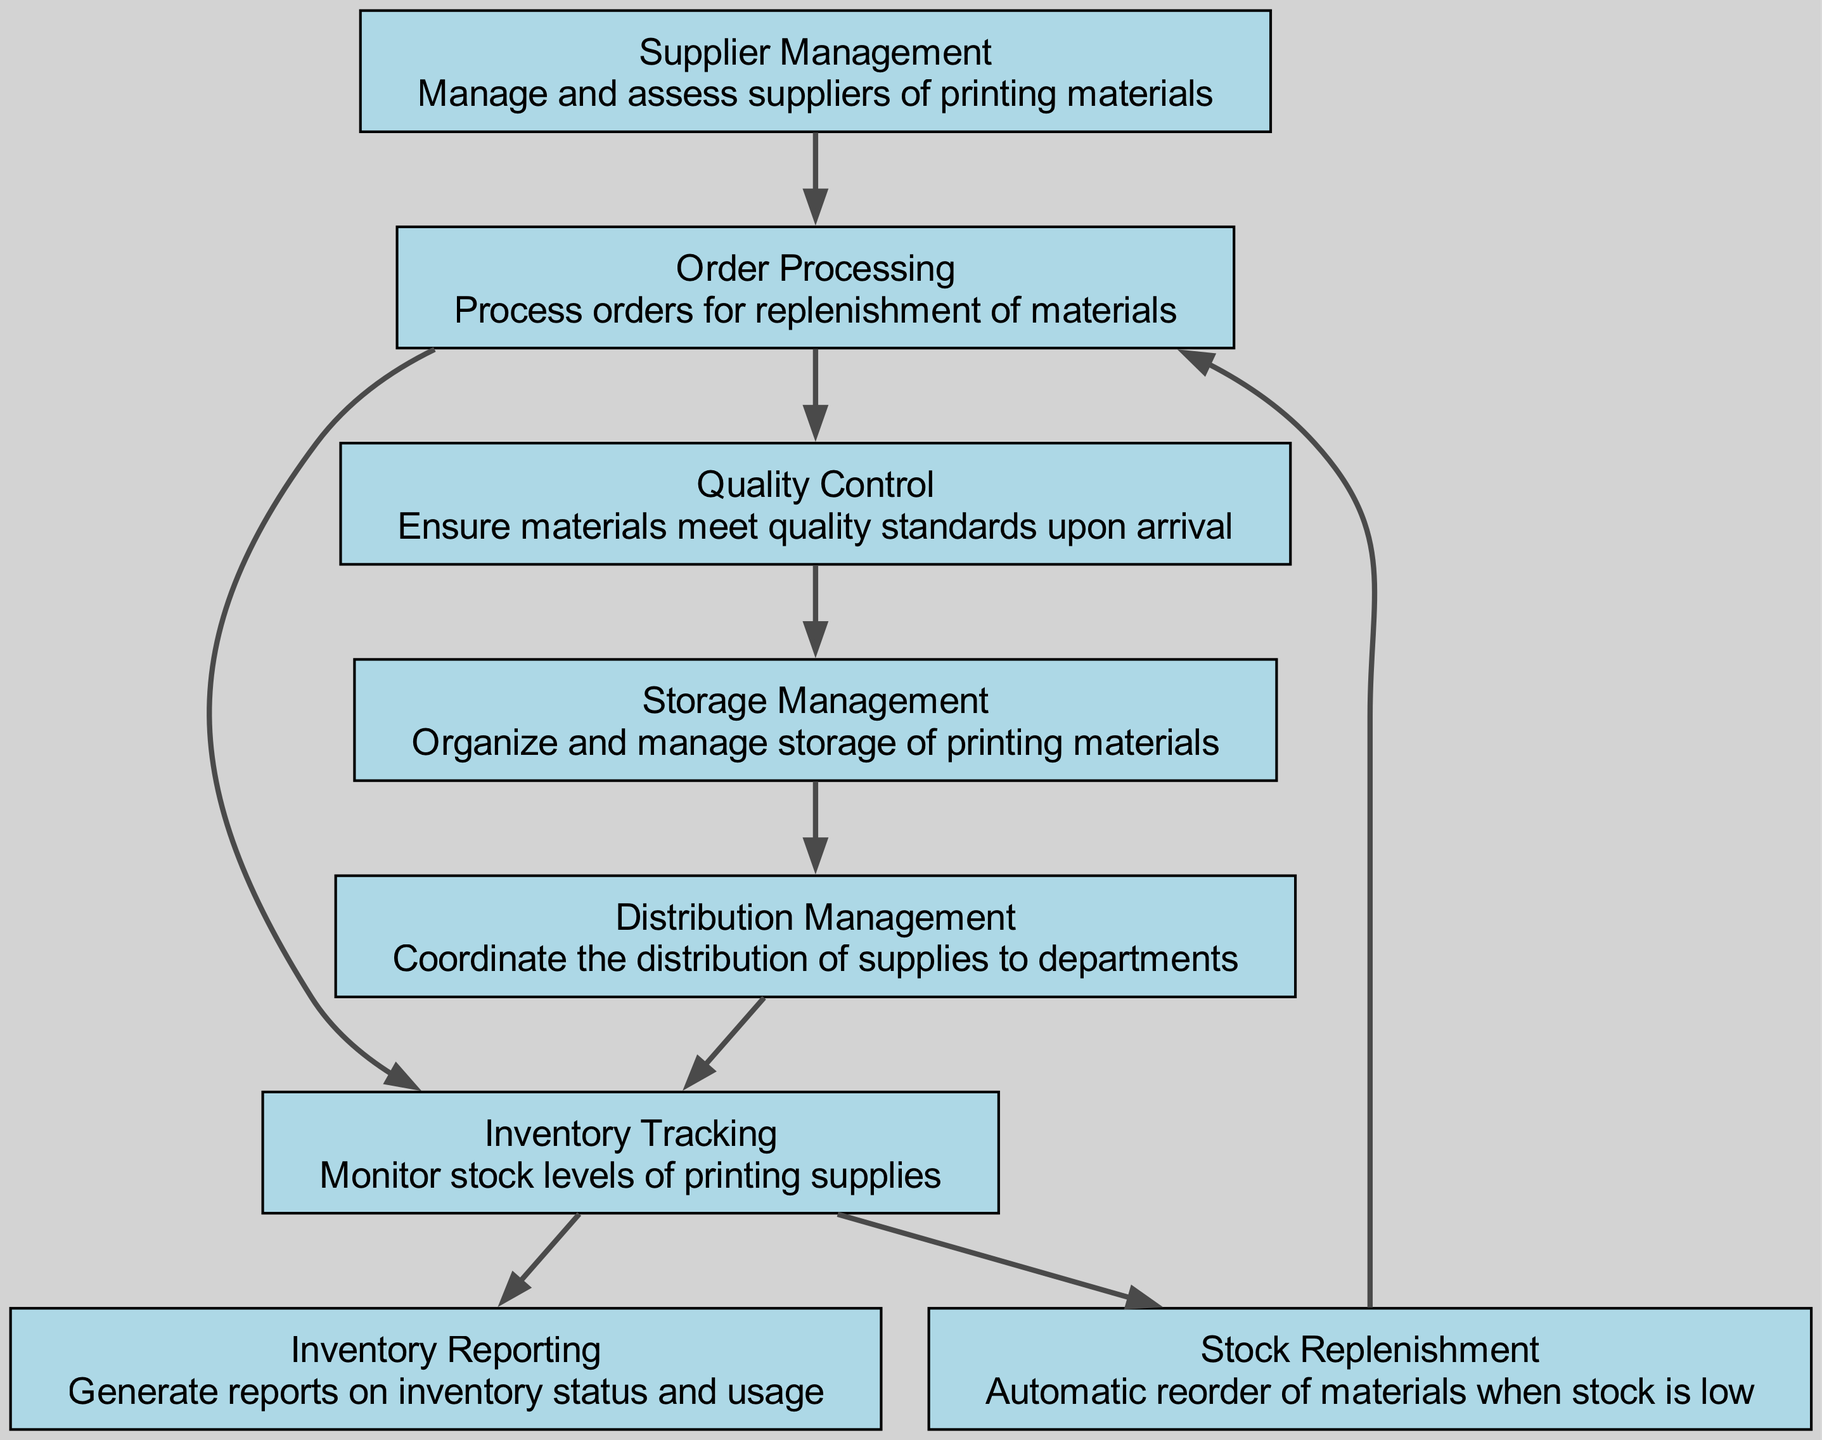What is the first step in the inventory management process? The first step in the process is identified as "Supplier Management". This is the starting point of the flow chart, indicating that managing suppliers is the initial action before moving further in inventory management.
Answer: Supplier Management How many nodes are present in the diagram? By counting the nodes listed, there are eight distinct elements representing various tasks or management functions in the inventory process. The total number of nodes is inclusive of supplier management, inventory tracking, order processing, quality control, stock replenishment, inventory reporting, storage management, and distribution management.
Answer: Eight What follows "Order Processing" in the flow of the diagram? The flow shows that "Order Processing" is directly followed by "Inventory Tracking", indicating that after processing an order, the next step is to monitor the stock levels of the printing supplies.
Answer: Inventory Tracking Which node is connected back to "Order Processing"? The diagram indicates that "Stock Replenishment" is connected back to "Order Processing". This shows that after replenishing stock, the cycle returns to processing more orders as needed.
Answer: Stock Replenishment What aspect of inventory management is conducted after quality control? The flow chart illustrates that after "Quality Control," the next step is "Storage Management". This means that once materials are checked for quality, they are organized and managed in storage.
Answer: Storage Management How does distribution management relate to inventory tracking? "Distribution Management" is connected back to "Inventory Tracking", meaning that after distributing supplies to departments, there is a need to monitor the stock levels again, thus creating a cycle of tracking and distributing.
Answer: Distribution Management Which process is responsible for ensuring quality standards? The node labeled "Quality Control" is specifically responsible for checking and ensuring that incoming materials meet the required quality standards before they proceed further in the process.
Answer: Quality Control What is generated as a final step in the inventory management system? The last node connected in the flow is "Inventory Reporting", indicating that after all processes have been completed, reports on inventory status and usage are generated to monitor overall management effectiveness.
Answer: Inventory Reporting 